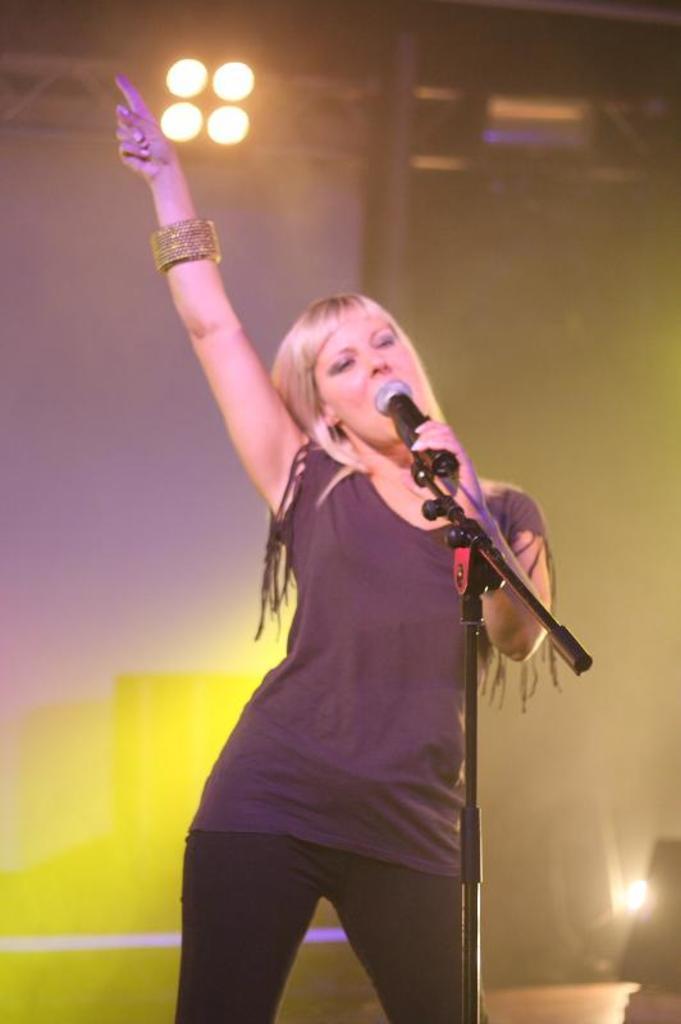In one or two sentences, can you explain what this image depicts? In this picture a girl is singing with a mic in her one of her hands. The picture is clicked in a musical concert. 